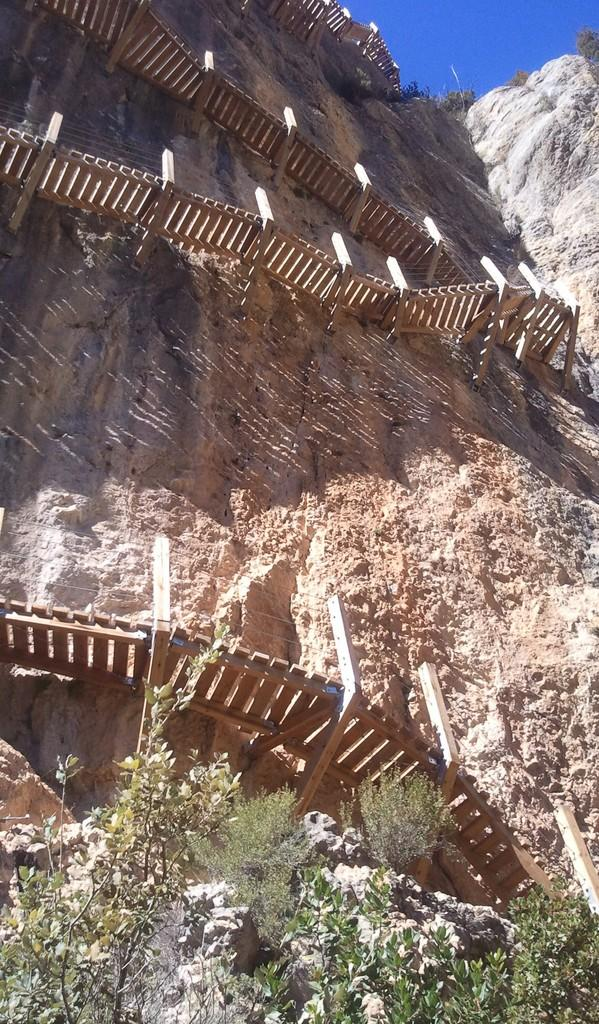What type of natural formation is present in the image? There is a rock mountain in the image. What kind of path can be seen in the image? There is a wooden path in the image. What type of barrier is visible in the image? There is fencing in the image. What type of vegetation is present in the image? There are trees in the image. What color is the sky in the image? The sky is blue in color. How much money is being exchanged between friends in the image? There are no friends or money present in the image. Where is the faucet located in the image? There is no faucet present in the image. 